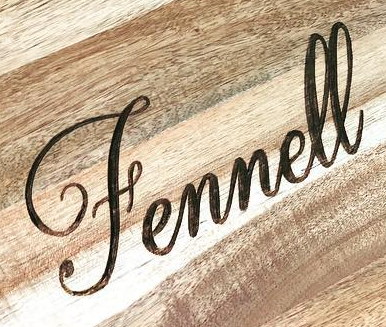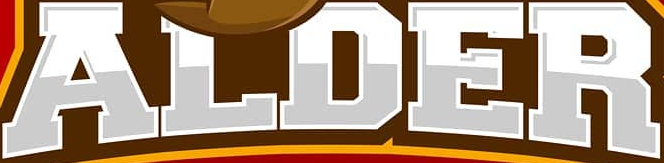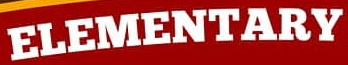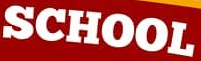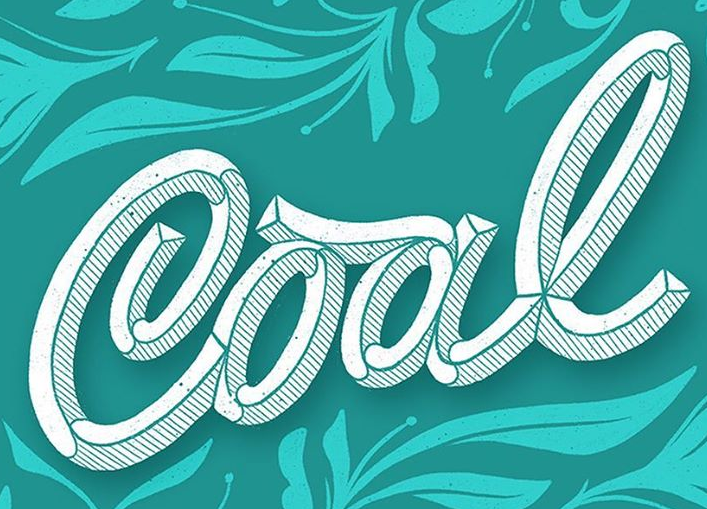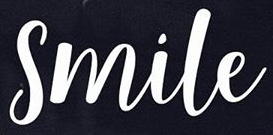Read the text from these images in sequence, separated by a semicolon. Fennell; ALDER; ELEMENTARY; SCHOOL; Cool; Smile 